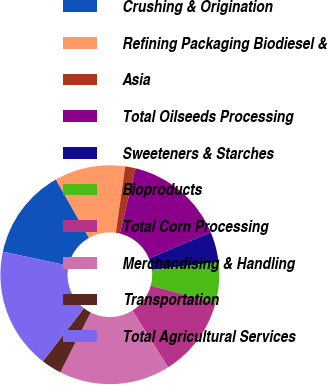Convert chart. <chart><loc_0><loc_0><loc_500><loc_500><pie_chart><fcel>Crushing & Origination<fcel>Refining Packaging Biodiesel &<fcel>Asia<fcel>Total Oilseeds Processing<fcel>Sweeteners & Starches<fcel>Bioproducts<fcel>Total Corn Processing<fcel>Merchandising & Handling<fcel>Transportation<fcel>Total Agricultural Services<nl><fcel>13.42%<fcel>10.45%<fcel>1.52%<fcel>14.91%<fcel>4.49%<fcel>5.98%<fcel>11.93%<fcel>16.4%<fcel>3.01%<fcel>17.89%<nl></chart> 